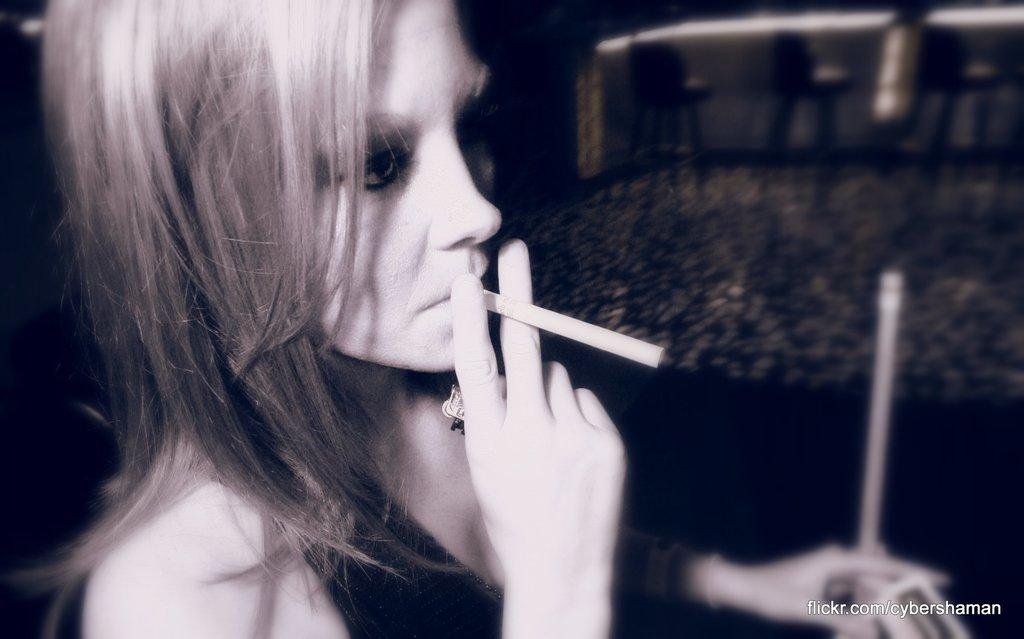Who is present in the image? There is a woman in the image. What is the woman holding in the image? The woman is holding a cigar. Can you describe the background of the image? The background of the woman is blurred. What type of net can be seen in the image? There is no net present in the image. How is the quartz being used in the image? There is no quartz present in the image. 